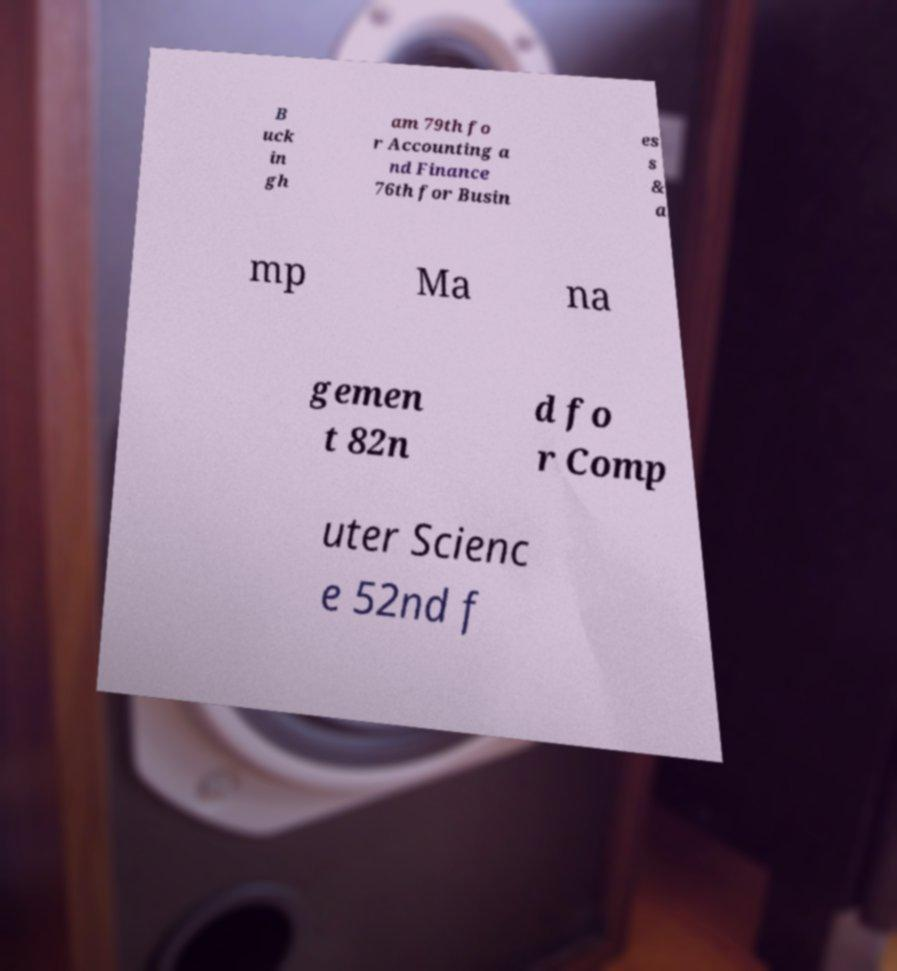For documentation purposes, I need the text within this image transcribed. Could you provide that? B uck in gh am 79th fo r Accounting a nd Finance 76th for Busin es s & a mp Ma na gemen t 82n d fo r Comp uter Scienc e 52nd f 